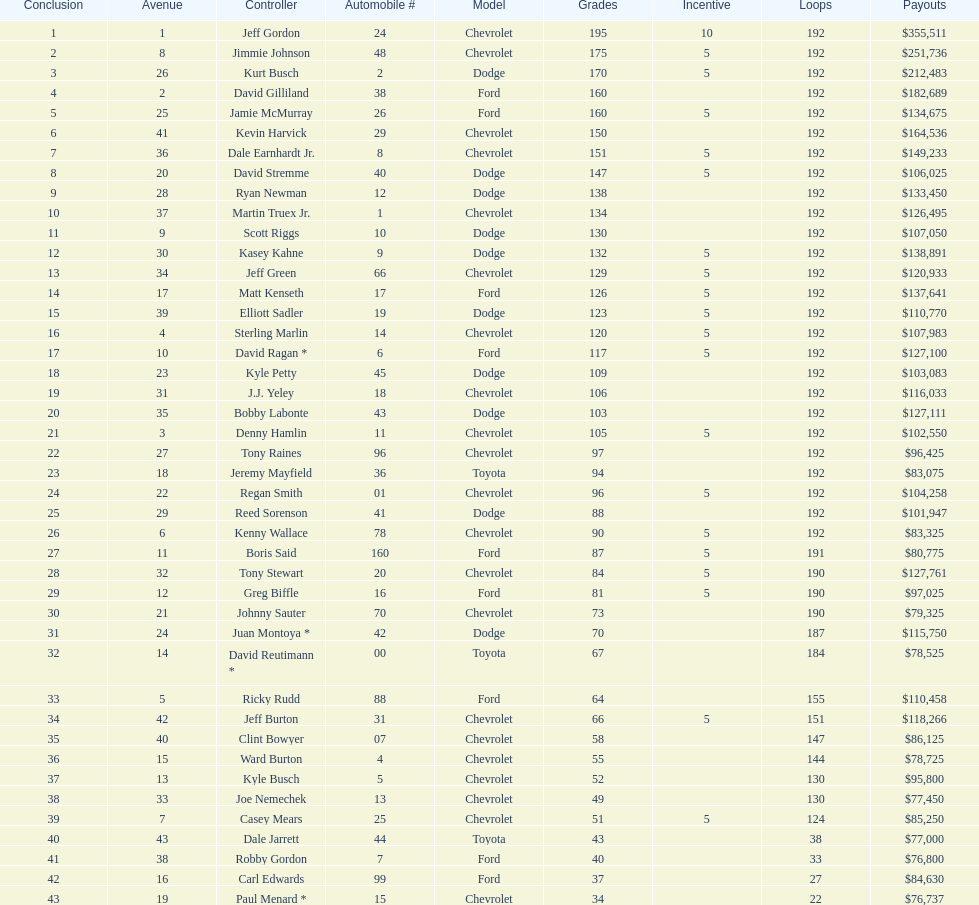What was jimmie johnson's winnings? $251,736. 